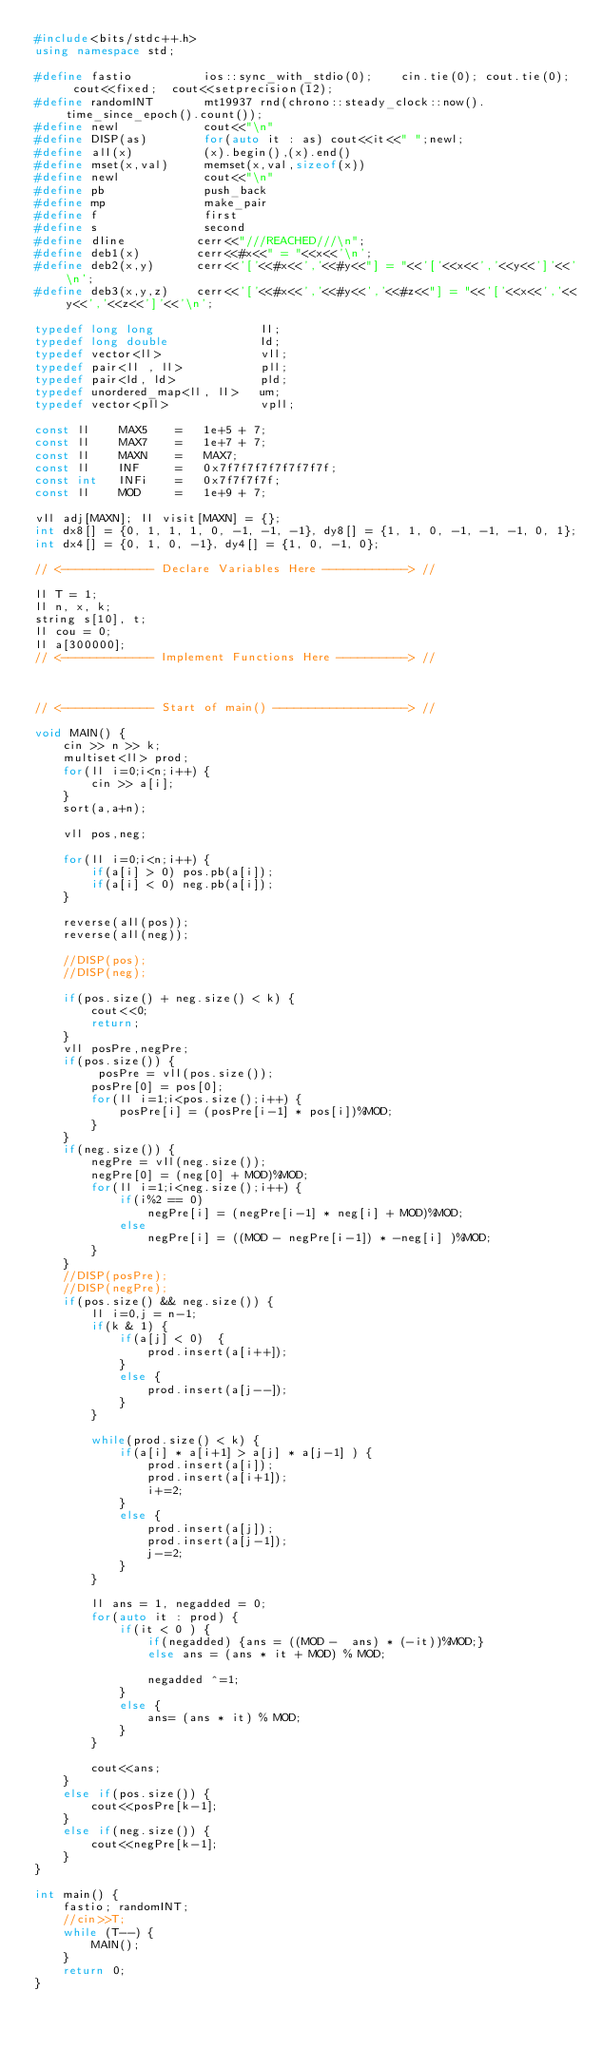<code> <loc_0><loc_0><loc_500><loc_500><_C++_>#include<bits/stdc++.h>
using namespace std;

#define fastio 			ios::sync_with_stdio(0);	cin.tie(0); cout.tie(0);  cout<<fixed;  cout<<setprecision(12);
#define randomINT 		mt19937 rnd(chrono::steady_clock::now().time_since_epoch().count());
#define	newl 			cout<<"\n"
#define DISP(as)		for(auto it : as) cout<<it<<" ";newl;
#define all(x)         	(x).begin(),(x).end()
#define mset(x,val)    	memset(x,val,sizeof(x))
#define newl           	cout<<"\n"
#define pb             	push_back
#define mp             	make_pair
#define f 				first
#define s 				second
#define dline          cerr<<"///REACHED///\n";
#define deb1(x)        cerr<<#x<<" = "<<x<<'\n';
#define deb2(x,y)      cerr<<'['<<#x<<','<<#y<<"] = "<<'['<<x<<','<<y<<']'<<'\n';
#define deb3(x,y,z)    cerr<<'['<<#x<<','<<#y<<','<<#z<<"] = "<<'['<<x<<','<<y<<','<<z<<']'<<'\n';

typedef long long 				ll;
typedef long double 			ld;
typedef vector<ll> 				vll;
typedef pair<ll , ll> 			pll;
typedef pair<ld, ld> 			pld;
typedef unordered_map<ll, ll> 	um;
typedef vector<pll> 			vpll;

const ll 	MAX5 	= 	1e+5 + 7;
const ll 	MAX7 	= 	1e+7 + 7;
const ll 	MAXN 	= 	MAX7;
const ll   	INF   	=  	0x7f7f7f7f7f7f7f7f;
const int  	INFi 	=  	0x7f7f7f7f;
const ll 	MOD		=  	1e+9 + 7;

vll adj[MAXN]; ll visit[MAXN] = {};
int dx8[] = {0, 1, 1, 1, 0, -1, -1, -1}, dy8[] = {1, 1, 0, -1, -1, -1, 0, 1};
int dx4[] = {0, 1, 0, -1}, dy4[] = {1, 0, -1, 0};

// <------------- Declare Variables Here ------------> //

ll T = 1;
ll n, x, k;
string s[10], t;
ll cou = 0;
ll a[300000];
// <------------- Implement Functions Here ----------> //



// <------------- Start of main() -------------------> //

void MAIN() {
	cin >> n >> k;
	multiset<ll> prod;
	for(ll i=0;i<n;i++) {
		cin >> a[i];
	}
	sort(a,a+n);

	vll pos,neg;
	
	for(ll i=0;i<n;i++) {
		if(a[i] > 0) pos.pb(a[i]);
		if(a[i] < 0) neg.pb(a[i]);
	}

	reverse(all(pos));
	reverse(all(neg));

	//DISP(pos);
	//DISP(neg);

	if(pos.size() + neg.size() < k) {
		cout<<0;
		return;
	}
	vll posPre,negPre;
	if(pos.size()) {
		 posPre = vll(pos.size());
		posPre[0] = pos[0];
		for(ll i=1;i<pos.size();i++) {
			posPre[i] = (posPre[i-1] * pos[i])%MOD;
		}
	}
	if(neg.size()) {
		negPre = vll(neg.size());
		negPre[0] = (neg[0] + MOD)%MOD;
		for(ll i=1;i<neg.size();i++) {
			if(i%2 == 0)
				negPre[i] = (negPre[i-1] * neg[i] + MOD)%MOD;
			else 
				negPre[i] = ((MOD - negPre[i-1]) * -neg[i] )%MOD;
		}
	}
	//DISP(posPre);
	//DISP(negPre);
	if(pos.size() && neg.size()) {
		ll i=0,j = n-1;
		if(k & 1) {
			if(a[j] < 0)  {
				prod.insert(a[i++]);
			}
			else {
				prod.insert(a[j--]);
			}
		}

		while(prod.size() < k) {
			if(a[i] * a[i+1] > a[j] * a[j-1] ) {
				prod.insert(a[i]);
				prod.insert(a[i+1]);
				i+=2;
			}
			else {
				prod.insert(a[j]);
				prod.insert(a[j-1]);
				j-=2;
			}
		}

		ll ans = 1, negadded = 0;
		for(auto it : prod) {
			if(it < 0 ) {
				if(negadded) {ans = ((MOD -  ans) * (-it))%MOD;}
				else ans = (ans * it + MOD) % MOD;

				negadded ^=1;
			}
			else {
				ans= (ans * it) % MOD;
			}
		}

		cout<<ans;
	}
	else if(pos.size()) {
		cout<<posPre[k-1];
	}
	else if(neg.size()) {
		cout<<negPre[k-1];
	}
}

int main() {
	fastio; randomINT;
	//cin>>T;
	while (T--) {
		MAIN();
	}
	return 0;
}
</code> 